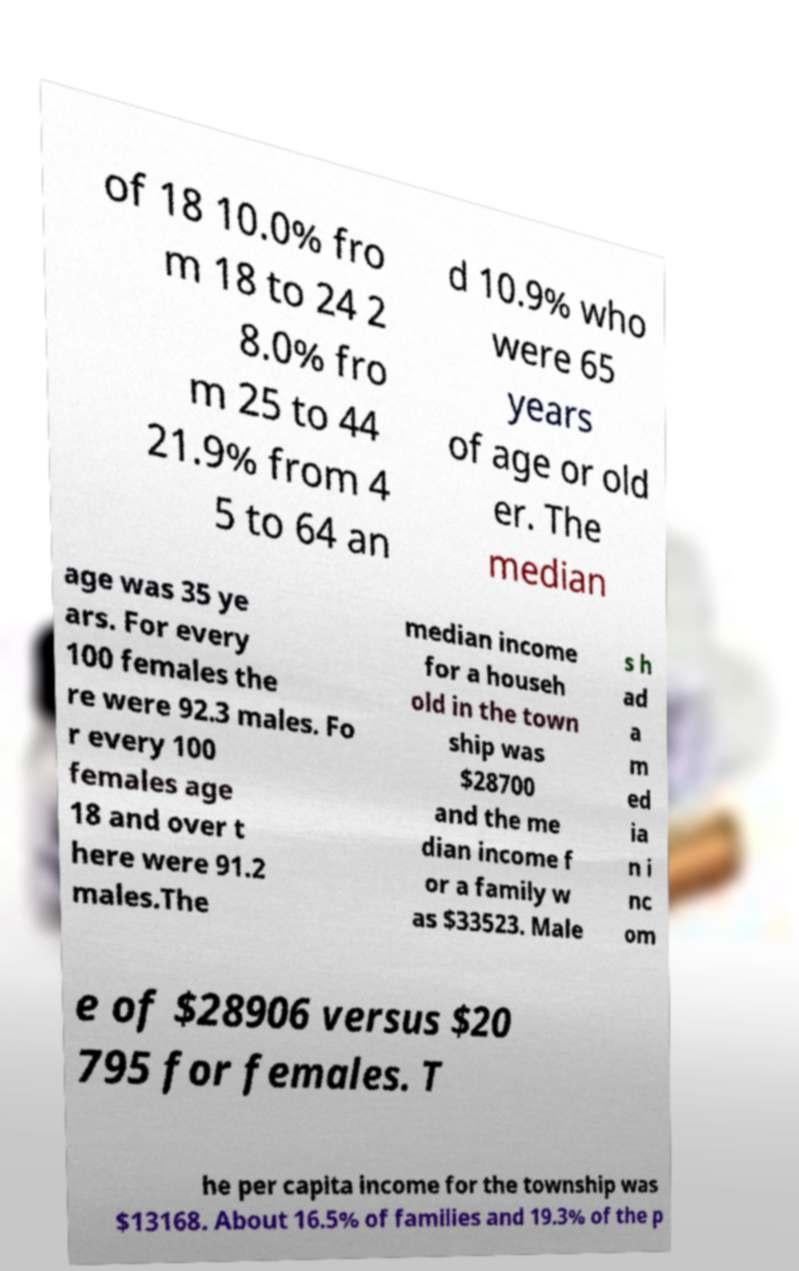For documentation purposes, I need the text within this image transcribed. Could you provide that? of 18 10.0% fro m 18 to 24 2 8.0% fro m 25 to 44 21.9% from 4 5 to 64 an d 10.9% who were 65 years of age or old er. The median age was 35 ye ars. For every 100 females the re were 92.3 males. Fo r every 100 females age 18 and over t here were 91.2 males.The median income for a househ old in the town ship was $28700 and the me dian income f or a family w as $33523. Male s h ad a m ed ia n i nc om e of $28906 versus $20 795 for females. T he per capita income for the township was $13168. About 16.5% of families and 19.3% of the p 